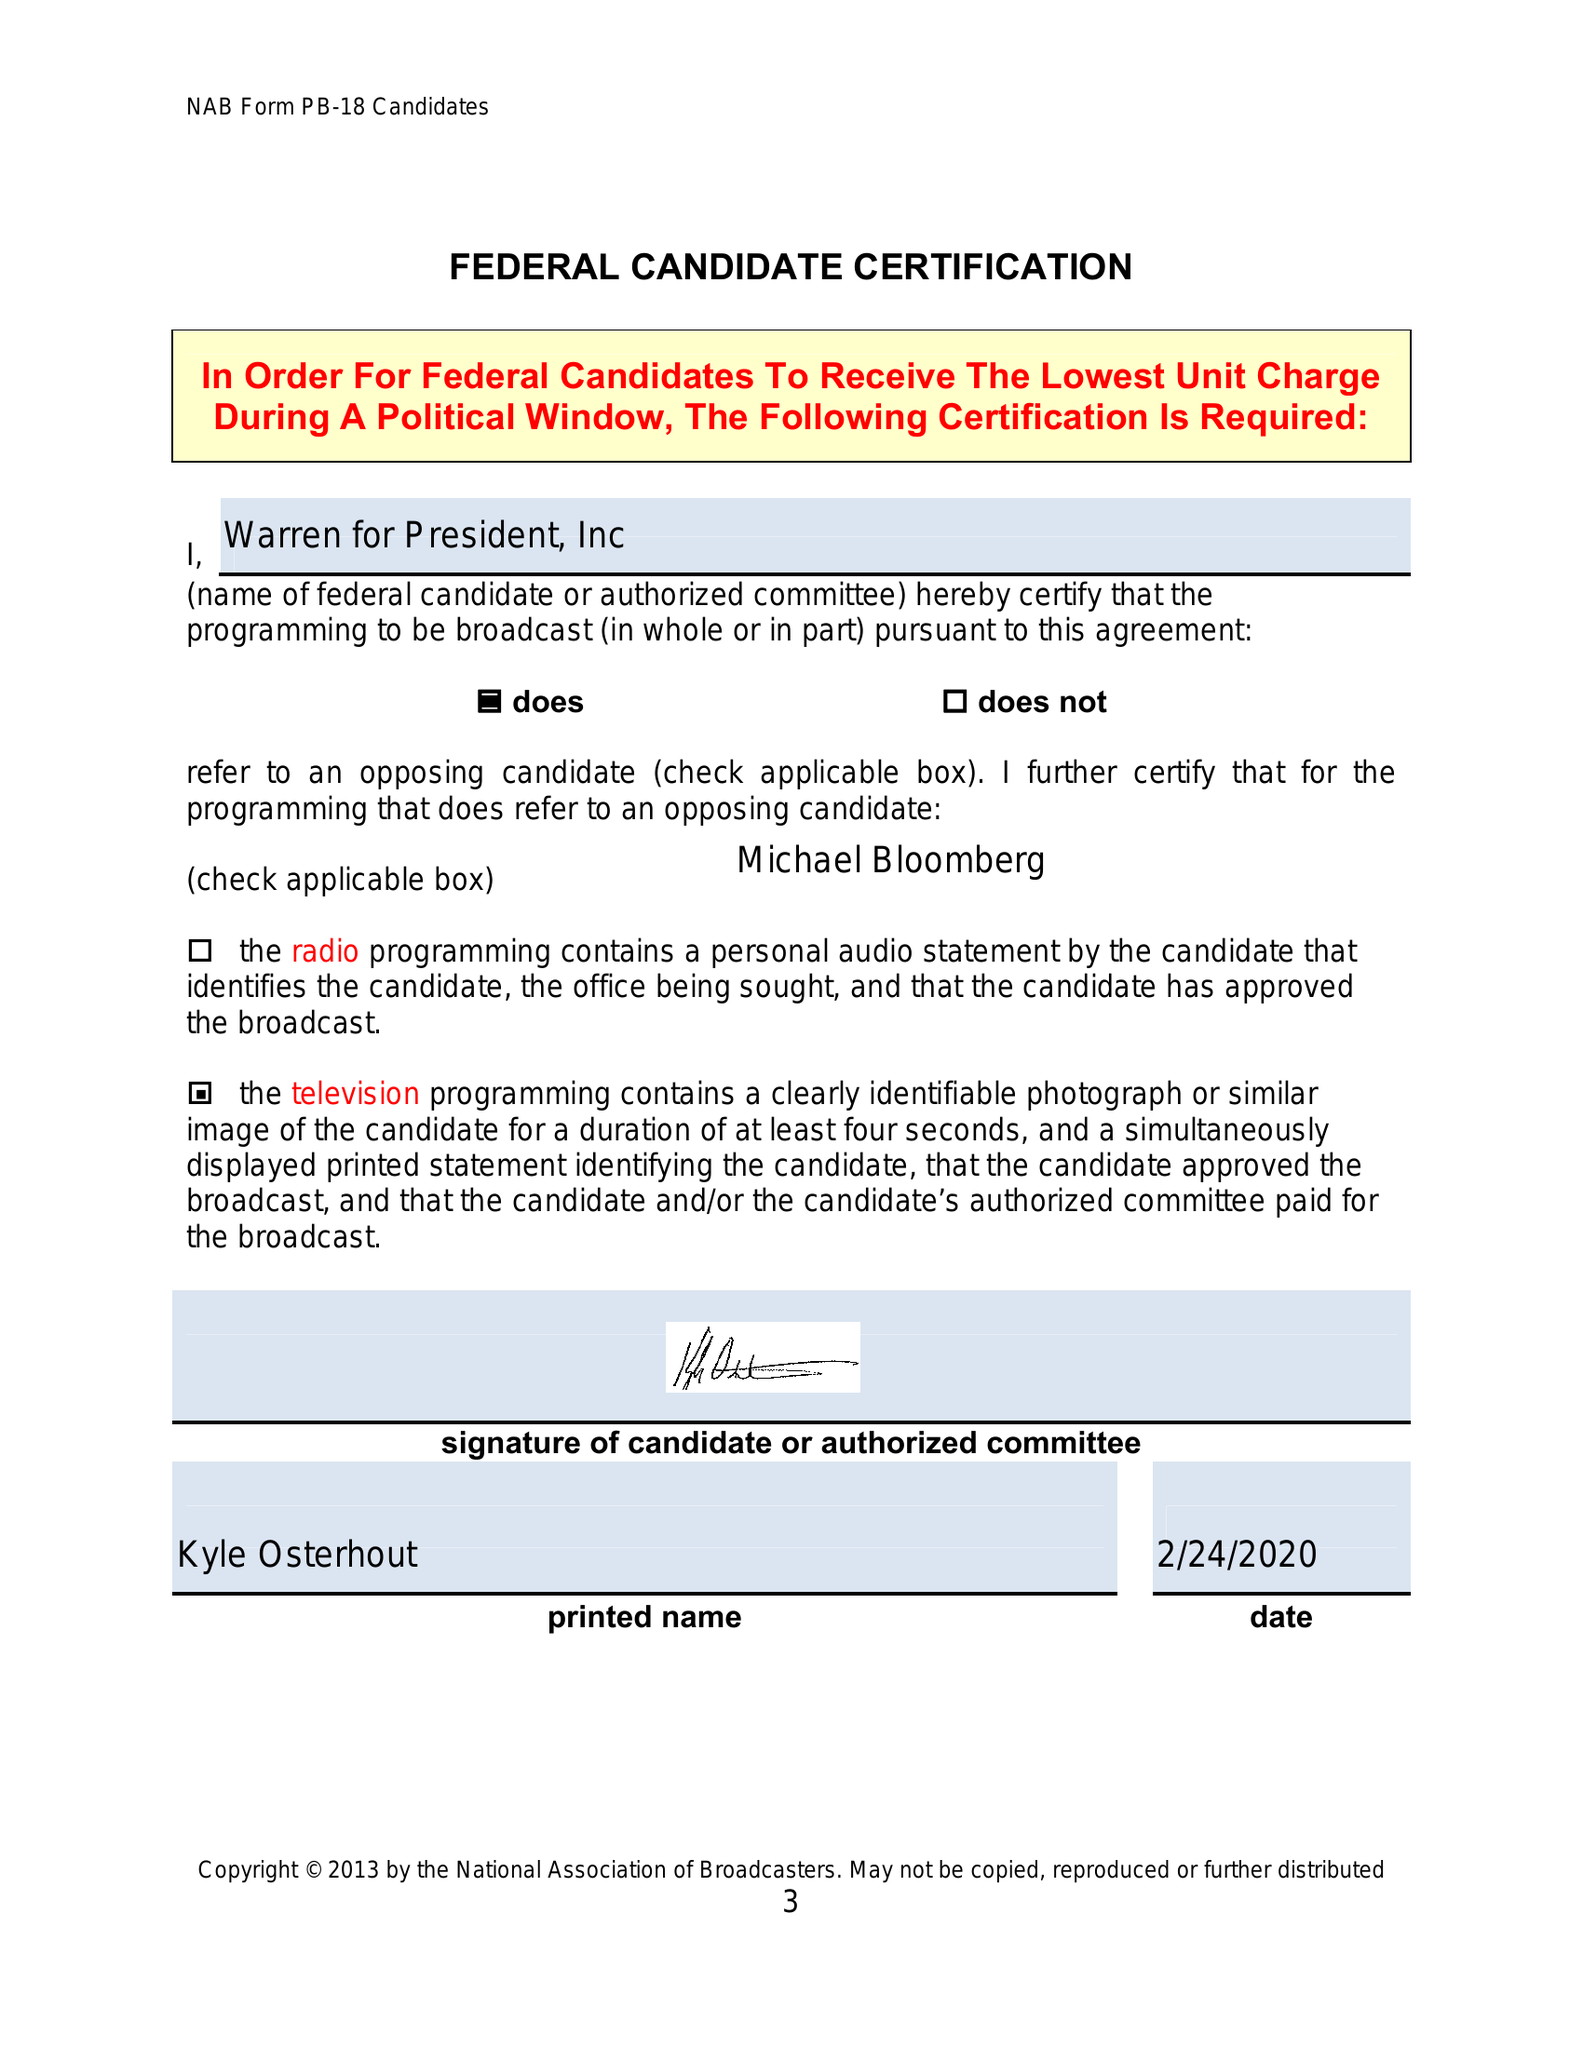What is the value for the flight_from?
Answer the question using a single word or phrase. None 